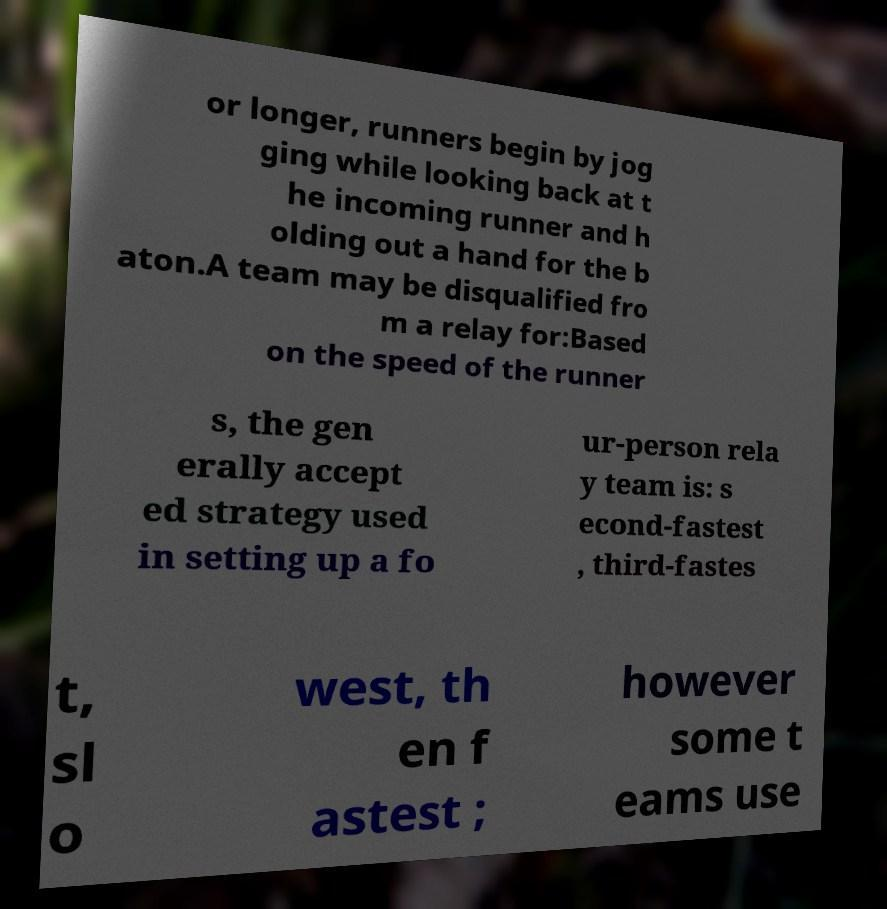For documentation purposes, I need the text within this image transcribed. Could you provide that? or longer, runners begin by jog ging while looking back at t he incoming runner and h olding out a hand for the b aton.A team may be disqualified fro m a relay for:Based on the speed of the runner s, the gen erally accept ed strategy used in setting up a fo ur-person rela y team is: s econd-fastest , third-fastes t, sl o west, th en f astest ; however some t eams use 